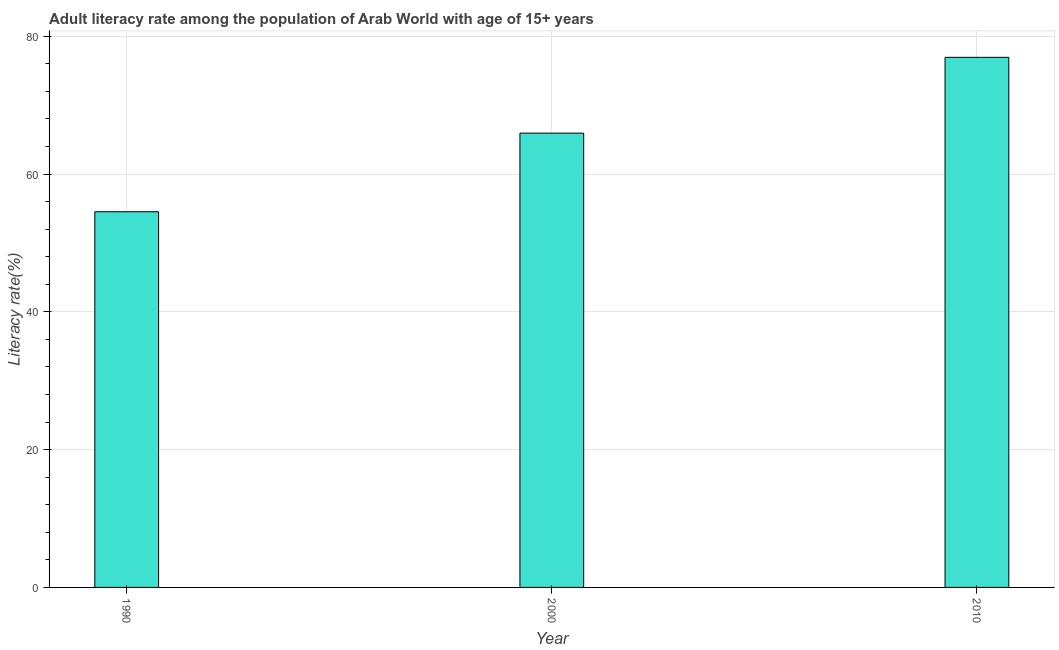Does the graph contain grids?
Offer a very short reply. Yes. What is the title of the graph?
Provide a short and direct response. Adult literacy rate among the population of Arab World with age of 15+ years. What is the label or title of the X-axis?
Give a very brief answer. Year. What is the label or title of the Y-axis?
Your answer should be very brief. Literacy rate(%). What is the adult literacy rate in 1990?
Keep it short and to the point. 54.54. Across all years, what is the maximum adult literacy rate?
Provide a succinct answer. 76.95. Across all years, what is the minimum adult literacy rate?
Offer a very short reply. 54.54. In which year was the adult literacy rate minimum?
Ensure brevity in your answer.  1990. What is the sum of the adult literacy rate?
Make the answer very short. 197.44. What is the difference between the adult literacy rate in 1990 and 2000?
Ensure brevity in your answer.  -11.41. What is the average adult literacy rate per year?
Your answer should be compact. 65.81. What is the median adult literacy rate?
Make the answer very short. 65.95. What is the ratio of the adult literacy rate in 2000 to that in 2010?
Provide a succinct answer. 0.86. Is the difference between the adult literacy rate in 2000 and 2010 greater than the difference between any two years?
Your answer should be compact. No. What is the difference between the highest and the second highest adult literacy rate?
Provide a short and direct response. 11. What is the difference between the highest and the lowest adult literacy rate?
Your response must be concise. 22.41. In how many years, is the adult literacy rate greater than the average adult literacy rate taken over all years?
Offer a terse response. 2. How many bars are there?
Offer a terse response. 3. How many years are there in the graph?
Ensure brevity in your answer.  3. What is the difference between two consecutive major ticks on the Y-axis?
Your answer should be very brief. 20. Are the values on the major ticks of Y-axis written in scientific E-notation?
Keep it short and to the point. No. What is the Literacy rate(%) in 1990?
Your response must be concise. 54.54. What is the Literacy rate(%) of 2000?
Make the answer very short. 65.95. What is the Literacy rate(%) of 2010?
Provide a succinct answer. 76.95. What is the difference between the Literacy rate(%) in 1990 and 2000?
Offer a very short reply. -11.41. What is the difference between the Literacy rate(%) in 1990 and 2010?
Make the answer very short. -22.41. What is the difference between the Literacy rate(%) in 2000 and 2010?
Keep it short and to the point. -11. What is the ratio of the Literacy rate(%) in 1990 to that in 2000?
Your response must be concise. 0.83. What is the ratio of the Literacy rate(%) in 1990 to that in 2010?
Provide a succinct answer. 0.71. What is the ratio of the Literacy rate(%) in 2000 to that in 2010?
Provide a succinct answer. 0.86. 